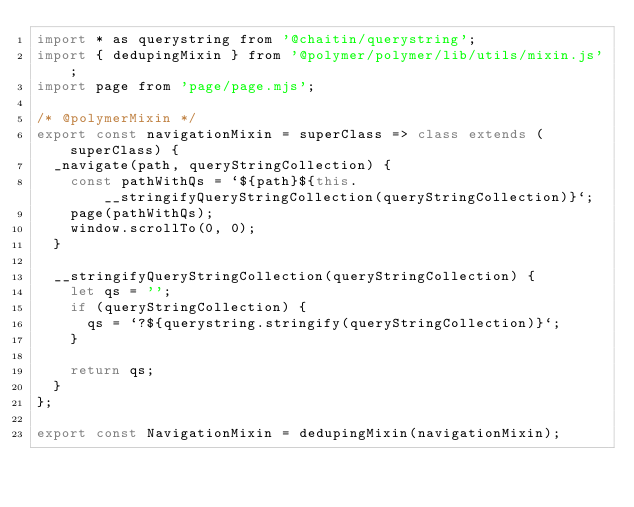<code> <loc_0><loc_0><loc_500><loc_500><_JavaScript_>import * as querystring from '@chaitin/querystring';
import { dedupingMixin } from '@polymer/polymer/lib/utils/mixin.js';
import page from 'page/page.mjs';

/* @polymerMixin */
export const navigationMixin = superClass => class extends (superClass) {
	_navigate(path, queryStringCollection) {
		const pathWithQs = `${path}${this.__stringifyQueryStringCollection(queryStringCollection)}`;
		page(pathWithQs);
		window.scrollTo(0, 0);
	}

	__stringifyQueryStringCollection(queryStringCollection) {
		let qs = '';
		if (queryStringCollection) {
			qs = `?${querystring.stringify(queryStringCollection)}`;
		}

		return qs;
	}
};

export const NavigationMixin = dedupingMixin(navigationMixin);
</code> 